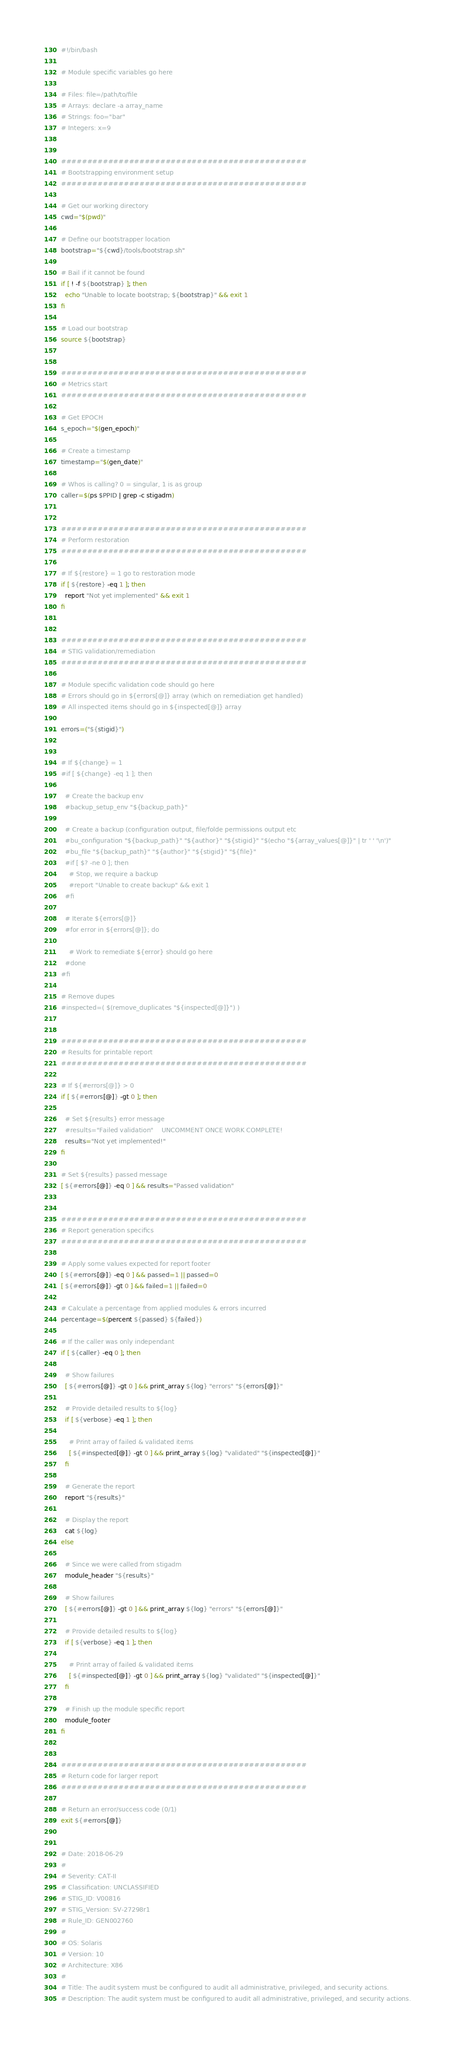Convert code to text. <code><loc_0><loc_0><loc_500><loc_500><_Bash_>#!/bin/bash

# Module specific variables go here

# Files: file=/path/to/file
# Arrays: declare -a array_name
# Strings: foo="bar"
# Integers: x=9


###############################################
# Bootstrapping environment setup
###############################################

# Get our working directory
cwd="$(pwd)"

# Define our bootstrapper location
bootstrap="${cwd}/tools/bootstrap.sh"

# Bail if it cannot be found
if [ ! -f ${bootstrap} ]; then
  echo "Unable to locate bootstrap; ${bootstrap}" && exit 1
fi

# Load our bootstrap
source ${bootstrap}


###############################################
# Metrics start
###############################################

# Get EPOCH
s_epoch="$(gen_epoch)"

# Create a timestamp
timestamp="$(gen_date)"

# Whos is calling? 0 = singular, 1 is as group
caller=$(ps $PPID | grep -c stigadm)


###############################################
# Perform restoration
###############################################

# If ${restore} = 1 go to restoration mode
if [ ${restore} -eq 1 ]; then
  report "Not yet implemented" && exit 1
fi


###############################################
# STIG validation/remediation
###############################################

# Module specific validation code should go here
# Errors should go in ${errors[@]} array (which on remediation get handled)
# All inspected items should go in ${inspected[@]} array

errors=("${stigid}")


# If ${change} = 1
#if [ ${change} -eq 1 ]; then

  # Create the backup env
  #backup_setup_env "${backup_path}"

  # Create a backup (configuration output, file/folde permissions output etc
  #bu_configuration "${backup_path}" "${author}" "${stigid}" "$(echo "${array_values[@]}" | tr ' ' '\n')"
  #bu_file "${backup_path}" "${author}" "${stigid}" "${file}"
  #if [ $? -ne 0 ]; then
    # Stop, we require a backup
    #report "Unable to create backup" && exit 1
  #fi

  # Iterate ${errors[@]}
  #for error in ${errors[@]}; do

    # Work to remediate ${error} should go here
  #done
#fi

# Remove dupes
#inspected=( $(remove_duplicates "${inspected[@]}") )


###############################################
# Results for printable report
###############################################

# If ${#errors[@]} > 0
if [ ${#errors[@]} -gt 0 ]; then

  # Set ${results} error message
  #results="Failed validation"    UNCOMMENT ONCE WORK COMPLETE!
  results="Not yet implemented!"
fi

# Set ${results} passed message
[ ${#errors[@]} -eq 0 ] && results="Passed validation"


###############################################
# Report generation specifics
###############################################

# Apply some values expected for report footer
[ ${#errors[@]} -eq 0 ] && passed=1 || passed=0
[ ${#errors[@]} -gt 0 ] && failed=1 || failed=0

# Calculate a percentage from applied modules & errors incurred
percentage=$(percent ${passed} ${failed})

# If the caller was only independant
if [ ${caller} -eq 0 ]; then

  # Show failures
  [ ${#errors[@]} -gt 0 ] && print_array ${log} "errors" "${errors[@]}"

  # Provide detailed results to ${log}
  if [ ${verbose} -eq 1 ]; then

    # Print array of failed & validated items
    [ ${#inspected[@]} -gt 0 ] && print_array ${log} "validated" "${inspected[@]}"
  fi

  # Generate the report
  report "${results}"

  # Display the report
  cat ${log}
else

  # Since we were called from stigadm
  module_header "${results}"

  # Show failures
  [ ${#errors[@]} -gt 0 ] && print_array ${log} "errors" "${errors[@]}"

  # Provide detailed results to ${log}
  if [ ${verbose} -eq 1 ]; then

    # Print array of failed & validated items
    [ ${#inspected[@]} -gt 0 ] && print_array ${log} "validated" "${inspected[@]}"
  fi

  # Finish up the module specific report
  module_footer
fi


###############################################
# Return code for larger report
###############################################

# Return an error/success code (0/1)
exit ${#errors[@]}


# Date: 2018-06-29
#
# Severity: CAT-II
# Classification: UNCLASSIFIED
# STIG_ID: V00816
# STIG_Version: SV-27298r1
# Rule_ID: GEN002760
#
# OS: Solaris
# Version: 10
# Architecture: X86
#
# Title: The audit system must be configured to audit all administrative, privileged, and security actions.
# Description: The audit system must be configured to audit all administrative, privileged, and security actions.

</code> 